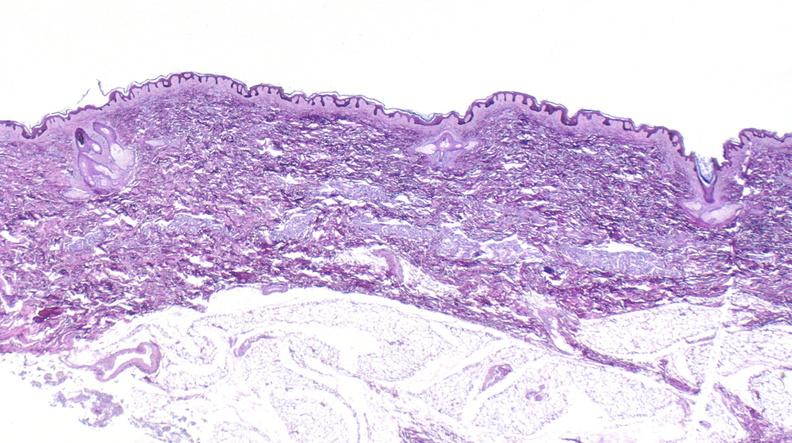where is this?
Answer the question using a single word or phrase. Skin 